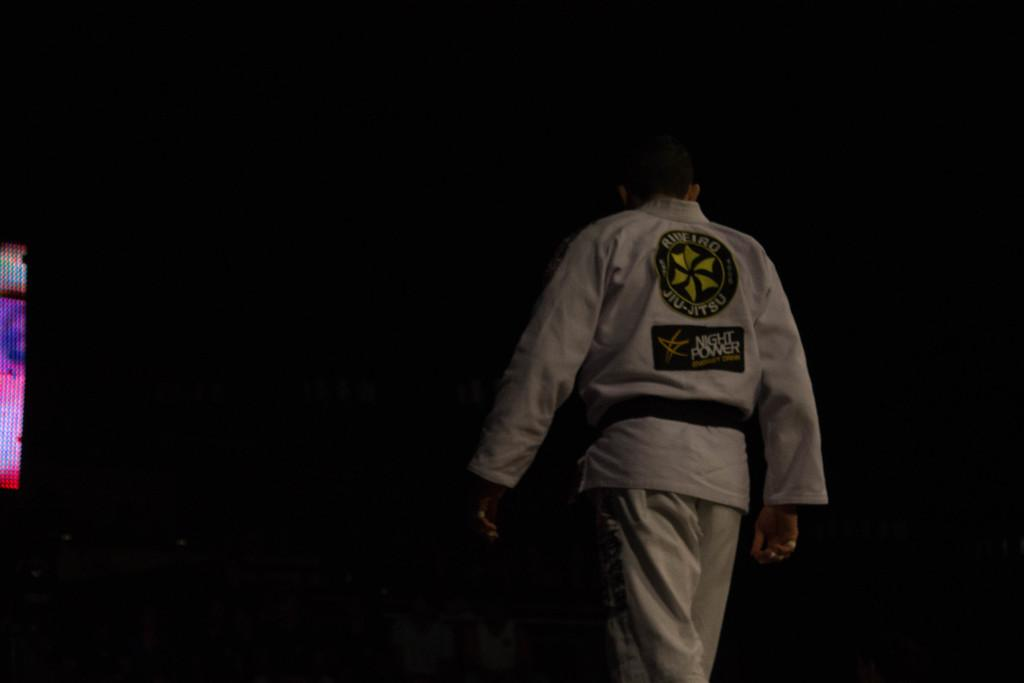<image>
Describe the image concisely. a person that is wearing a Jiu Jitsu outfit 